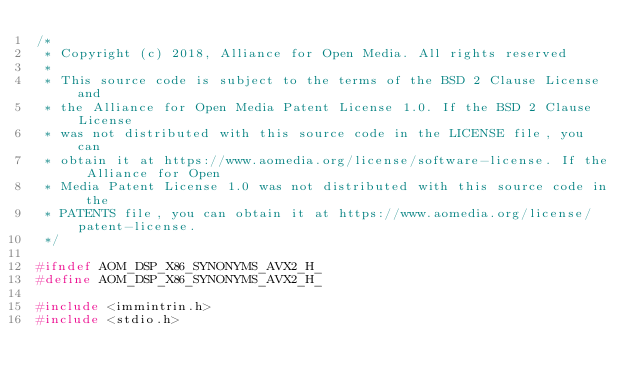Convert code to text. <code><loc_0><loc_0><loc_500><loc_500><_C_>/*
 * Copyright (c) 2018, Alliance for Open Media. All rights reserved
 *
 * This source code is subject to the terms of the BSD 2 Clause License and
 * the Alliance for Open Media Patent License 1.0. If the BSD 2 Clause License
 * was not distributed with this source code in the LICENSE file, you can
 * obtain it at https://www.aomedia.org/license/software-license. If the Alliance for Open
 * Media Patent License 1.0 was not distributed with this source code in the
 * PATENTS file, you can obtain it at https://www.aomedia.org/license/patent-license.
 */

#ifndef AOM_DSP_X86_SYNONYMS_AVX2_H_
#define AOM_DSP_X86_SYNONYMS_AVX2_H_

#include <immintrin.h>
#include <stdio.h>
</code> 